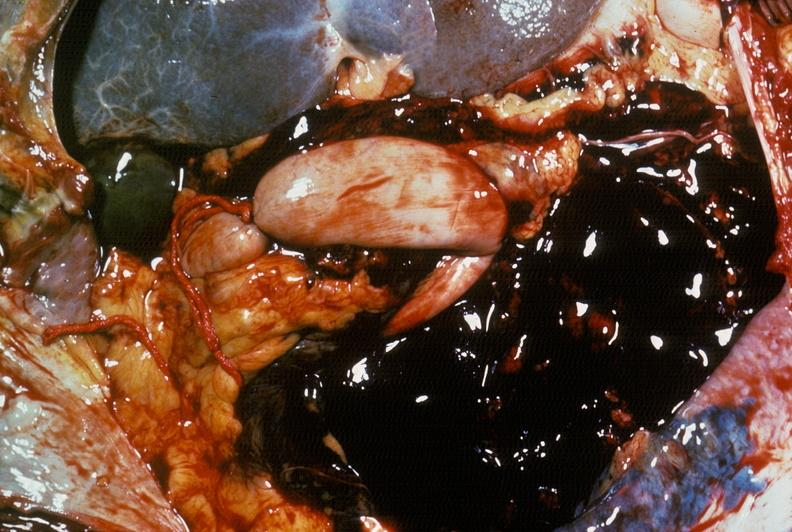s abdomen present?
Answer the question using a single word or phrase. Yes 